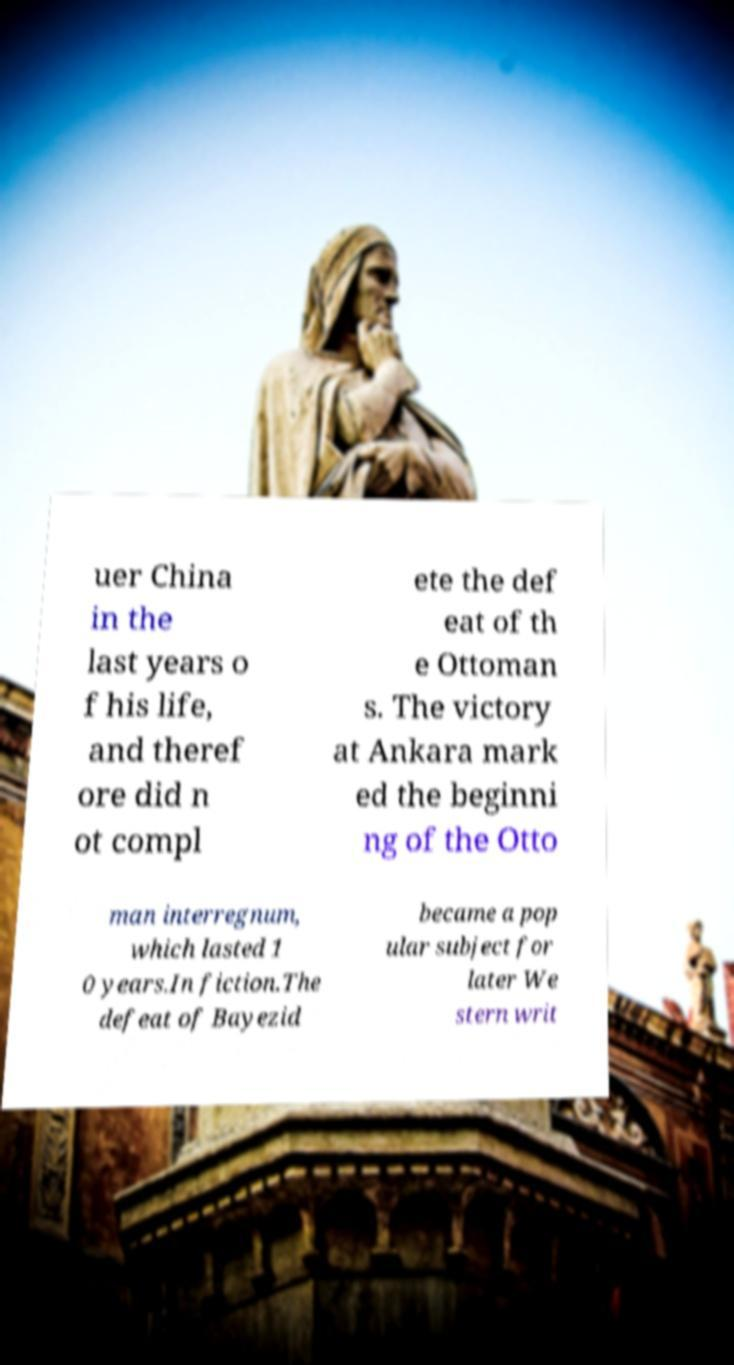For documentation purposes, I need the text within this image transcribed. Could you provide that? uer China in the last years o f his life, and theref ore did n ot compl ete the def eat of th e Ottoman s. The victory at Ankara mark ed the beginni ng of the Otto man interregnum, which lasted 1 0 years.In fiction.The defeat of Bayezid became a pop ular subject for later We stern writ 